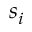Convert formula to latex. <formula><loc_0><loc_0><loc_500><loc_500>s _ { i }</formula> 